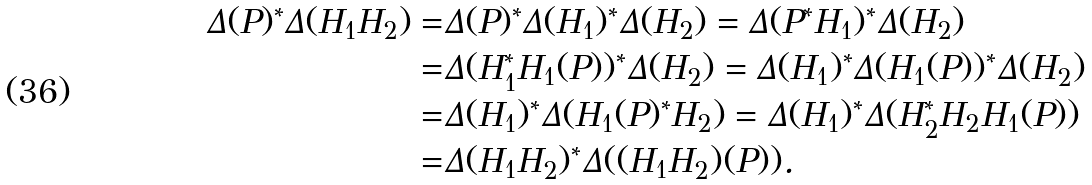Convert formula to latex. <formula><loc_0><loc_0><loc_500><loc_500>\Delta ( P ) ^ { * } \Delta ( H _ { 1 } H _ { 2 } ) = & \Delta ( P ) ^ { * } \Delta ( H _ { 1 } ) ^ { * } \Delta ( H _ { 2 } ) = \Delta ( P ^ { * } H _ { 1 } ) ^ { * } \Delta ( H _ { 2 } ) \\ = & \Delta ( H _ { 1 } ^ { * } H _ { 1 } ( P ) ) ^ { * } \Delta ( H _ { 2 } ) = \Delta ( H _ { 1 } ) ^ { * } \Delta ( H _ { 1 } ( P ) ) ^ { * } \Delta ( H _ { 2 } ) \\ = & \Delta ( H _ { 1 } ) ^ { * } \Delta ( H _ { 1 } ( P ) ^ { * } H _ { 2 } ) = \Delta ( H _ { 1 } ) ^ { * } \Delta ( H _ { 2 } ^ { * } H _ { 2 } H _ { 1 } ( P ) ) \\ = & \Delta ( H _ { 1 } H _ { 2 } ) ^ { * } \Delta ( ( H _ { 1 } H _ { 2 } ) ( P ) ) .</formula> 